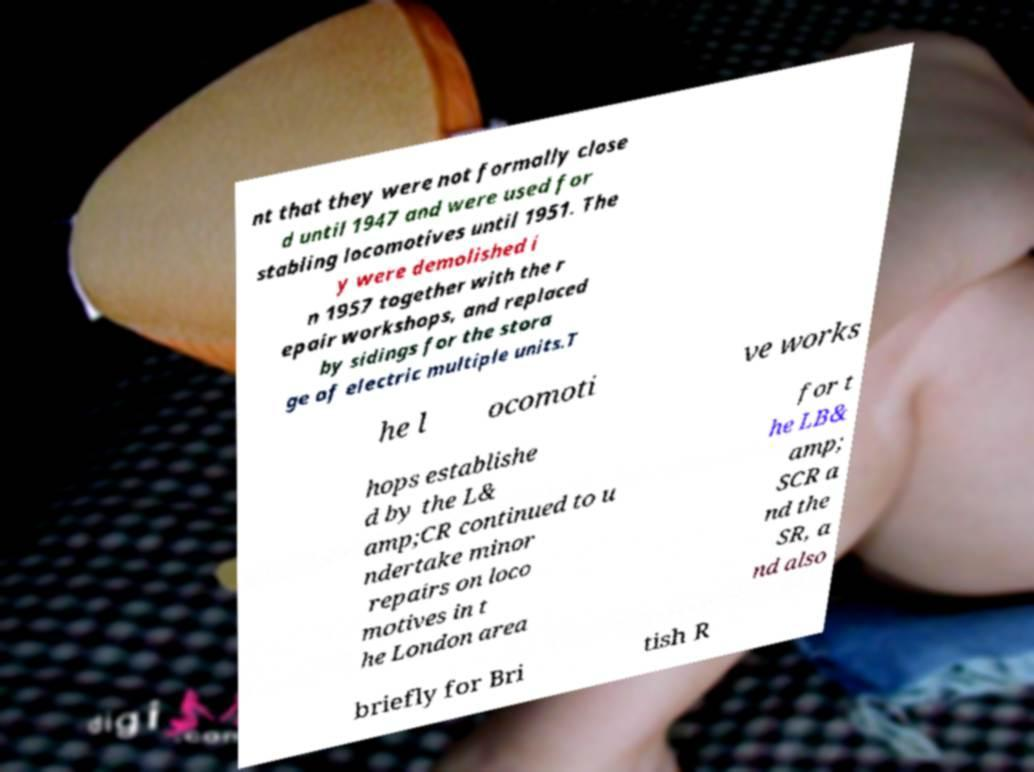Could you extract and type out the text from this image? nt that they were not formally close d until 1947 and were used for stabling locomotives until 1951. The y were demolished i n 1957 together with the r epair workshops, and replaced by sidings for the stora ge of electric multiple units.T he l ocomoti ve works hops establishe d by the L& amp;CR continued to u ndertake minor repairs on loco motives in t he London area for t he LB& amp; SCR a nd the SR, a nd also briefly for Bri tish R 